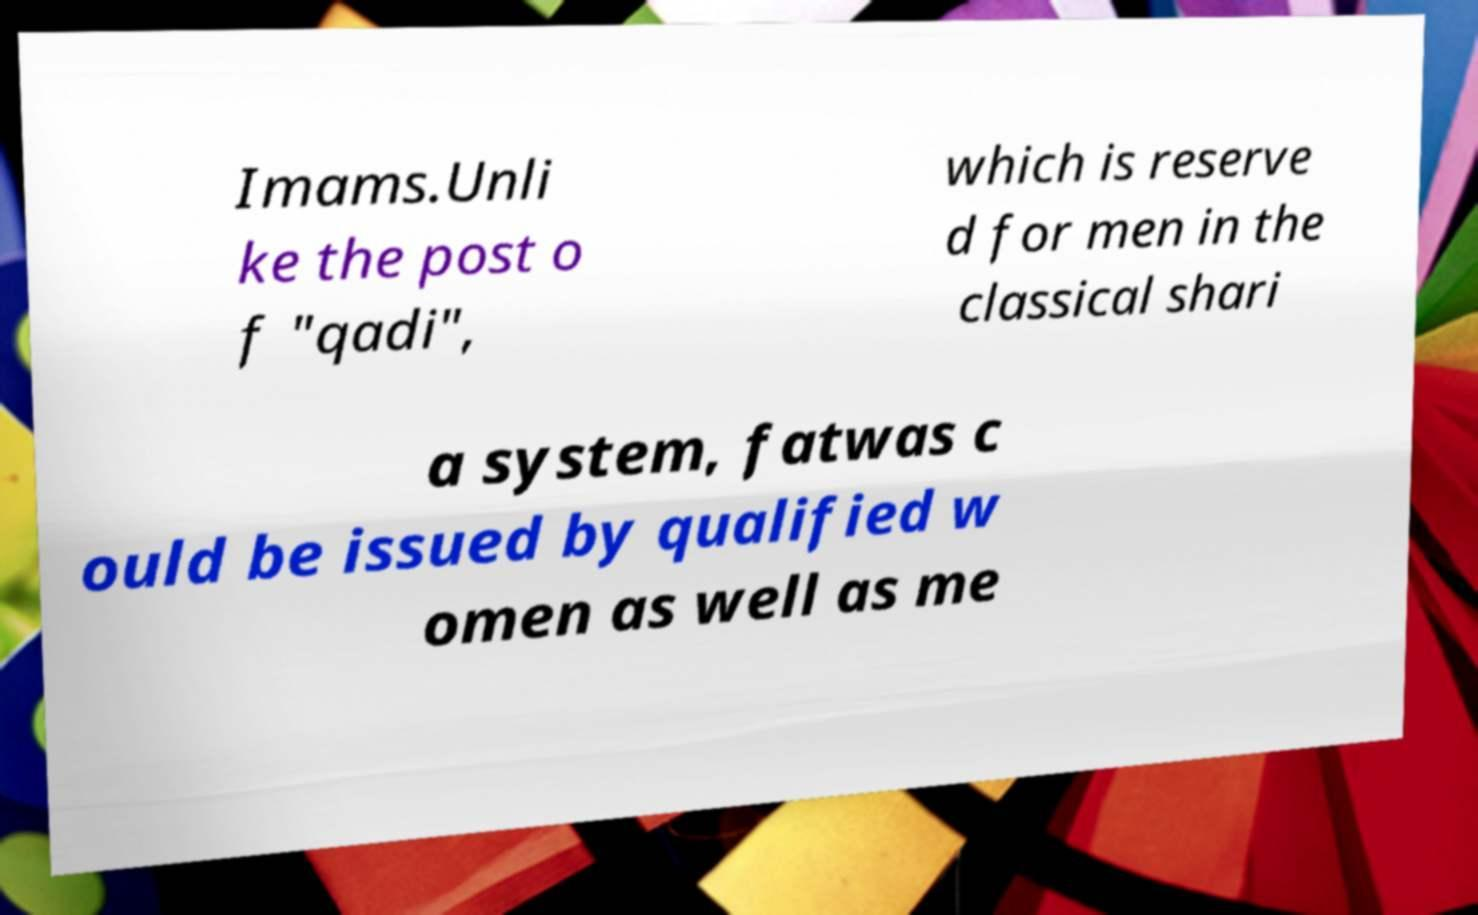Please read and relay the text visible in this image. What does it say? Imams.Unli ke the post o f "qadi", which is reserve d for men in the classical shari a system, fatwas c ould be issued by qualified w omen as well as me 